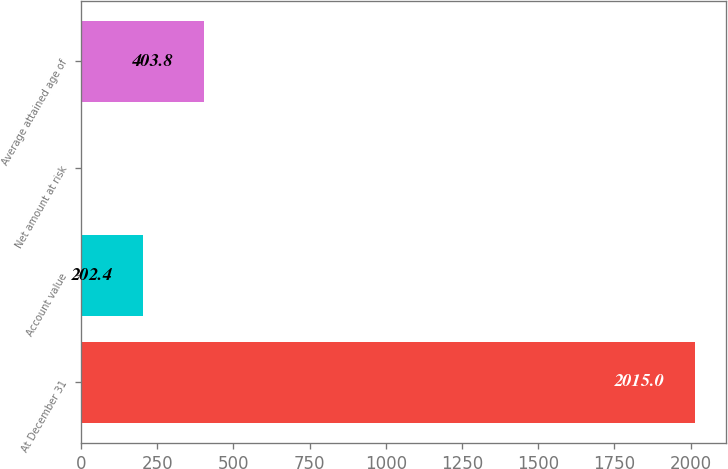Convert chart. <chart><loc_0><loc_0><loc_500><loc_500><bar_chart><fcel>At December 31<fcel>Account value<fcel>Net amount at risk<fcel>Average attained age of<nl><fcel>2015<fcel>202.4<fcel>1<fcel>403.8<nl></chart> 